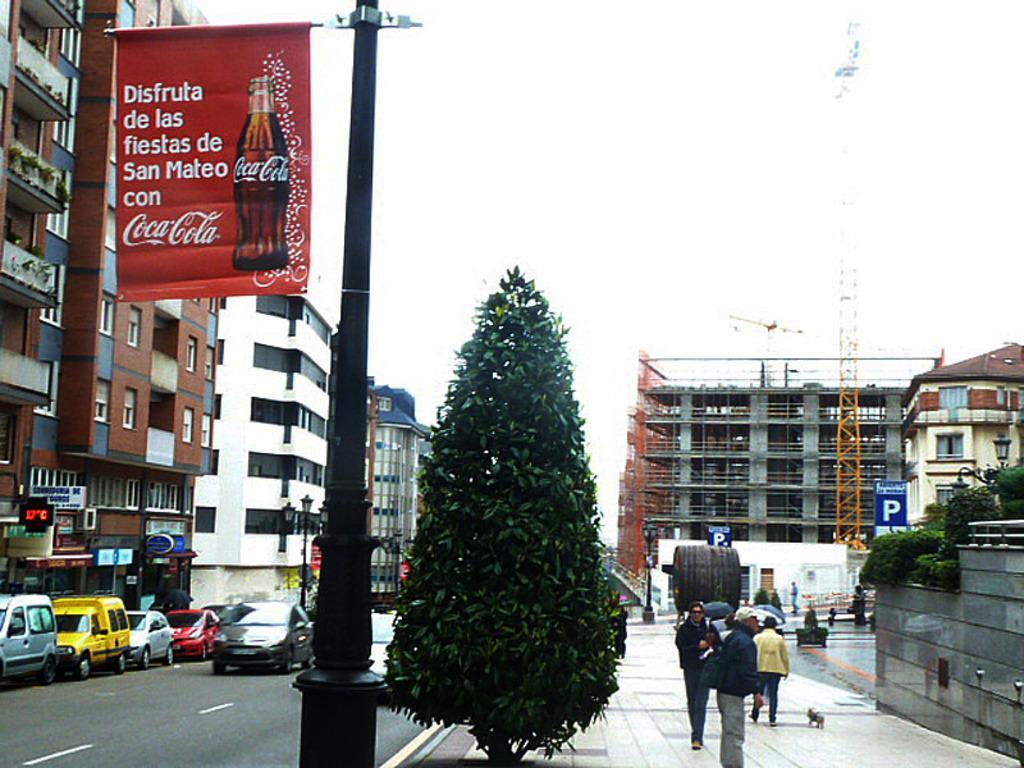Describe this image in one or two sentences. In this image we can see few buildings and there are some vehicles on the road and there is a pole with a banner and we can see some text and a bottle image on it. There are few people on the right side of the image and we can see some trees and at the top we can see the sky. 